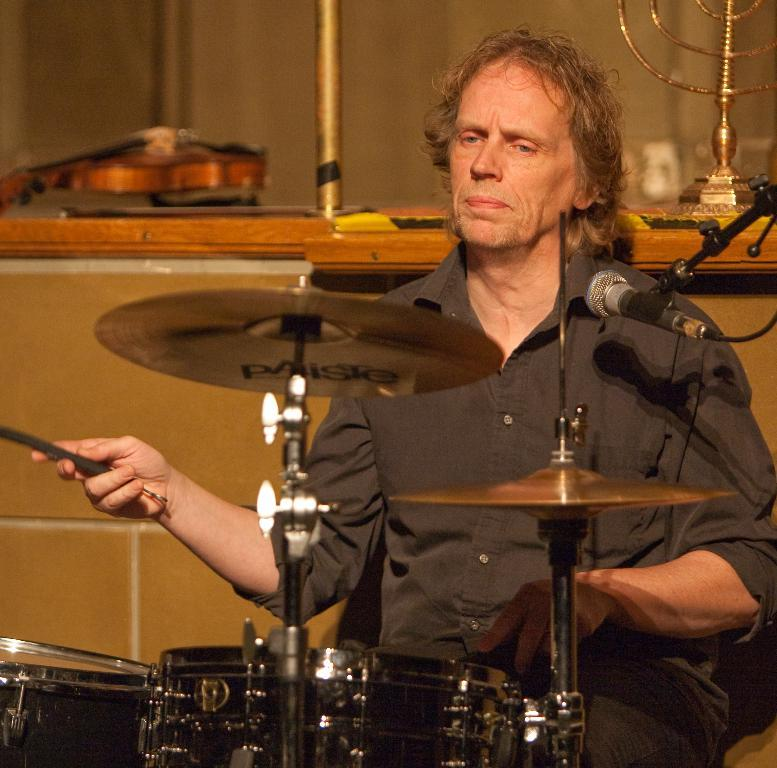What is the main subject of the image? The main subject of the image is a man sitting in the center. What is the man doing in the image? The man is playing a band in the image. Can you describe the background of the image? There are musical instruments placed on the wall in the background of the image. How many birds are flying in the image? There are no birds visible in the image. 